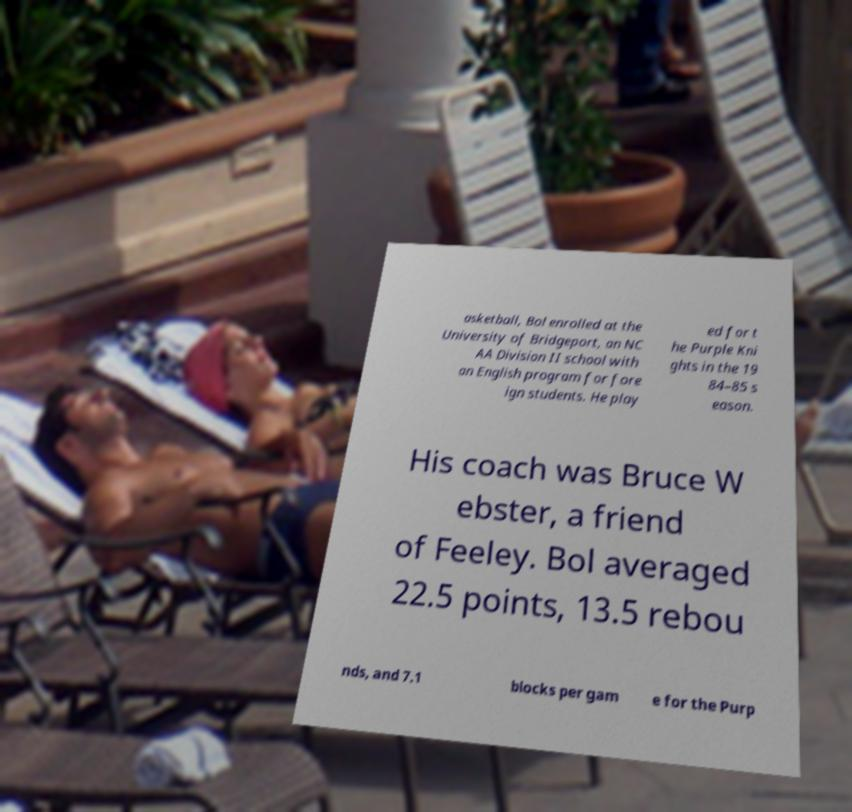Could you assist in decoding the text presented in this image and type it out clearly? asketball, Bol enrolled at the University of Bridgeport, an NC AA Division II school with an English program for fore ign students. He play ed for t he Purple Kni ghts in the 19 84–85 s eason. His coach was Bruce W ebster, a friend of Feeley. Bol averaged 22.5 points, 13.5 rebou nds, and 7.1 blocks per gam e for the Purp 